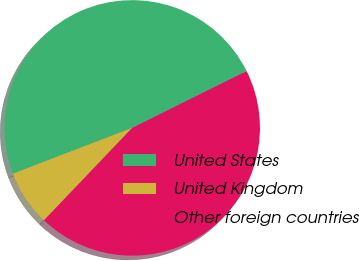Convert chart to OTSL. <chart><loc_0><loc_0><loc_500><loc_500><pie_chart><fcel>United States<fcel>United Kingdom<fcel>Other foreign countries<nl><fcel>48.49%<fcel>7.05%<fcel>44.47%<nl></chart> 